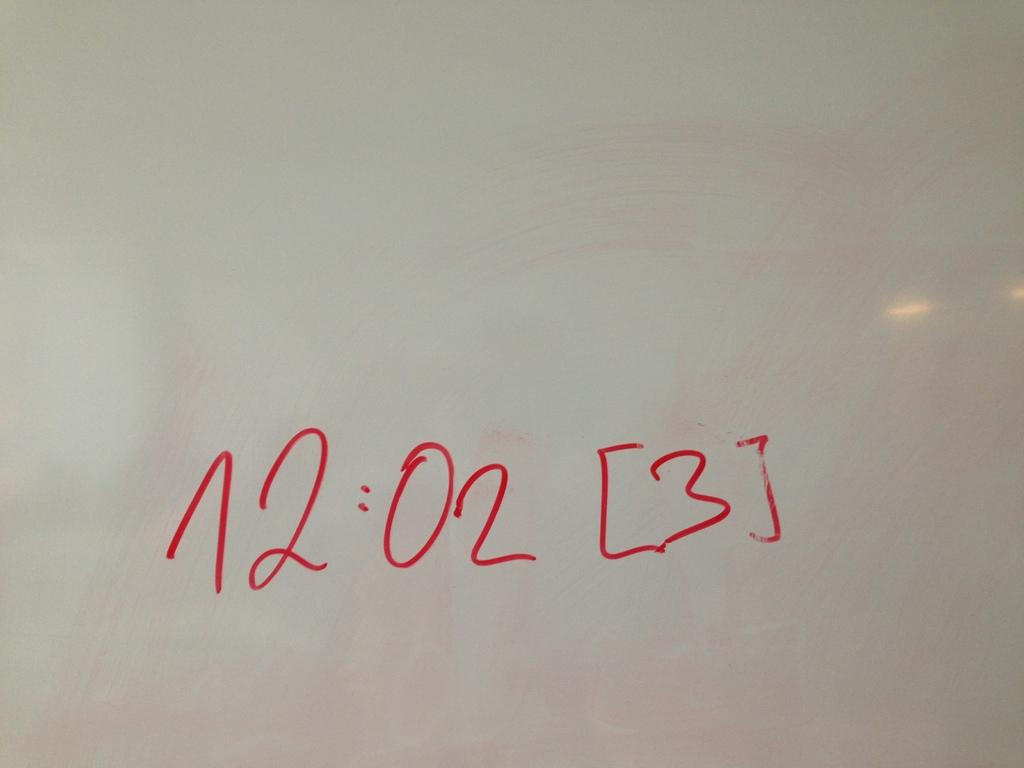What is the main feature of the image? There is text in the center of the image. What color is the background of the image? The background of the image is white. Can you identify any specific material in the image? It appears that there is glass in the image. How much snow is visible in the image? There is no snow present in the image. What type of produce can be seen in the image? There is no produce present in the image. 